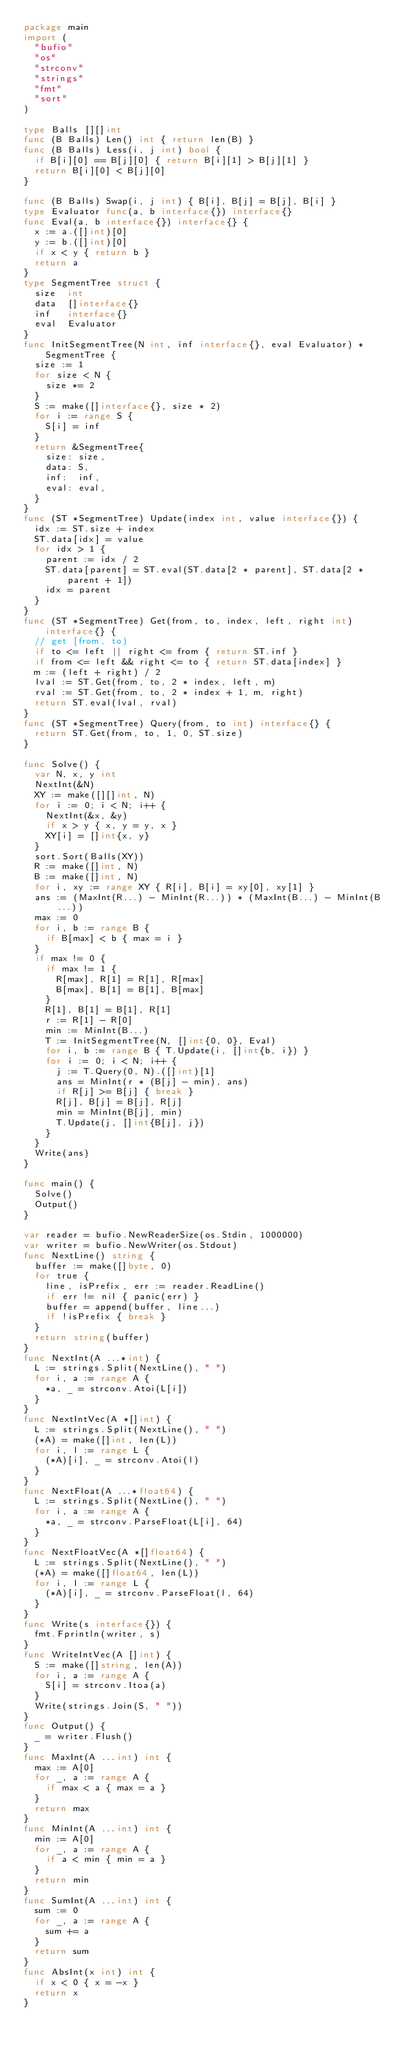<code> <loc_0><loc_0><loc_500><loc_500><_Go_>package main
import (
  "bufio"
  "os"
  "strconv"
  "strings"
  "fmt"
  "sort"
)

type Balls [][]int
func (B Balls) Len() int { return len(B) }
func (B Balls) Less(i, j int) bool {
  if B[i][0] == B[j][0] { return B[i][1] > B[j][1] }
  return B[i][0] < B[j][0]
}

func (B Balls) Swap(i, j int) { B[i], B[j] = B[j], B[i] }
type Evaluator func(a, b interface{}) interface{}
func Eval(a, b interface{}) interface{} {
  x := a.([]int)[0]
  y := b.([]int)[0]
  if x < y { return b }
  return a
}
type SegmentTree struct {
  size  int
  data  []interface{}
  inf   interface{}
  eval  Evaluator
}
func InitSegmentTree(N int, inf interface{}, eval Evaluator) *SegmentTree {
  size := 1
  for size < N {
    size *= 2
  }
  S := make([]interface{}, size * 2)
  for i := range S {
    S[i] = inf
  }
  return &SegmentTree{
    size: size,
    data: S,
    inf:  inf,
    eval: eval,
  }
}
func (ST *SegmentTree) Update(index int, value interface{}) {
  idx := ST.size + index
  ST.data[idx] = value
  for idx > 1 {
    parent := idx / 2
    ST.data[parent] = ST.eval(ST.data[2 * parent], ST.data[2 * parent + 1])
    idx = parent
  }
}
func (ST *SegmentTree) Get(from, to, index, left, right int) interface{} {
  // get [from, to)
  if to <= left || right <= from { return ST.inf }
  if from <= left && right <= to { return ST.data[index] }
  m := (left + right) / 2
  lval := ST.Get(from, to, 2 * index, left, m)
  rval := ST.Get(from, to, 2 * index + 1, m, right)
  return ST.eval(lval, rval)
}
func (ST *SegmentTree) Query(from, to int) interface{} {
  return ST.Get(from, to, 1, 0, ST.size)
}

func Solve() {
  var N, x, y int
  NextInt(&N)
  XY := make([][]int, N)
  for i := 0; i < N; i++ {
    NextInt(&x, &y)
    if x > y { x, y = y, x }
    XY[i] = []int{x, y}
  }
  sort.Sort(Balls(XY))
  R := make([]int, N)
  B := make([]int, N)
  for i, xy := range XY { R[i], B[i] = xy[0], xy[1] }
  ans := (MaxInt(R...) - MinInt(R...)) * (MaxInt(B...) - MinInt(B...))
  max := 0
  for i, b := range B {
    if B[max] < b { max = i }
  }
  if max != 0 {
    if max != 1 {
      R[max], R[1] = R[1], R[max]
      B[max], B[1] = B[1], B[max]
    }
    R[1], B[1] = B[1], R[1]
    r := R[1] - R[0]
    min := MinInt(B...)
    T := InitSegmentTree(N, []int{0, 0}, Eval)
    for i, b := range B { T.Update(i, []int{b, i}) }
    for i := 0; i < N; i++ {
      j := T.Query(0, N).([]int)[1]
      ans = MinInt(r * (B[j] - min), ans)
      if R[j] >= B[j] { break }
      R[j], B[j] = B[j], R[j]
      min = MinInt(B[j], min)
      T.Update(j, []int{B[j], j})
    }
  }
  Write(ans)
}

func main() {
  Solve()
  Output()
}

var reader = bufio.NewReaderSize(os.Stdin, 1000000)
var writer = bufio.NewWriter(os.Stdout)
func NextLine() string {
  buffer := make([]byte, 0)
  for true {
    line, isPrefix, err := reader.ReadLine()
    if err != nil { panic(err) }
    buffer = append(buffer, line...)
    if !isPrefix { break }
  }
  return string(buffer)
}
func NextInt(A ...*int) {
  L := strings.Split(NextLine(), " ")
  for i, a := range A {
    *a, _ = strconv.Atoi(L[i])
  }
}
func NextIntVec(A *[]int) {
  L := strings.Split(NextLine(), " ")
  (*A) = make([]int, len(L))
  for i, l := range L {
    (*A)[i], _ = strconv.Atoi(l)
  }
}
func NextFloat(A ...*float64) {
  L := strings.Split(NextLine(), " ")
  for i, a := range A {
    *a, _ = strconv.ParseFloat(L[i], 64)
  }
}
func NextFloatVec(A *[]float64) {
  L := strings.Split(NextLine(), " ")
  (*A) = make([]float64, len(L))
  for i, l := range L {
    (*A)[i], _ = strconv.ParseFloat(l, 64)
  }
}
func Write(s interface{}) {
  fmt.Fprintln(writer, s)
}
func WriteIntVec(A []int) {
  S := make([]string, len(A))
  for i, a := range A {
    S[i] = strconv.Itoa(a)
  }
  Write(strings.Join(S, " "))
}
func Output() {
  _ = writer.Flush()
}
func MaxInt(A ...int) int {
  max := A[0]
  for _, a := range A {
    if max < a { max = a }
  }
  return max
}
func MinInt(A ...int) int {
  min := A[0]
  for _, a := range A {
    if a < min { min = a }
  }
  return min
}
func SumInt(A ...int) int {
  sum := 0
  for _, a := range A {
    sum += a
  }
  return sum
}
func AbsInt(x int) int {
  if x < 0 { x = -x }
  return x
}</code> 